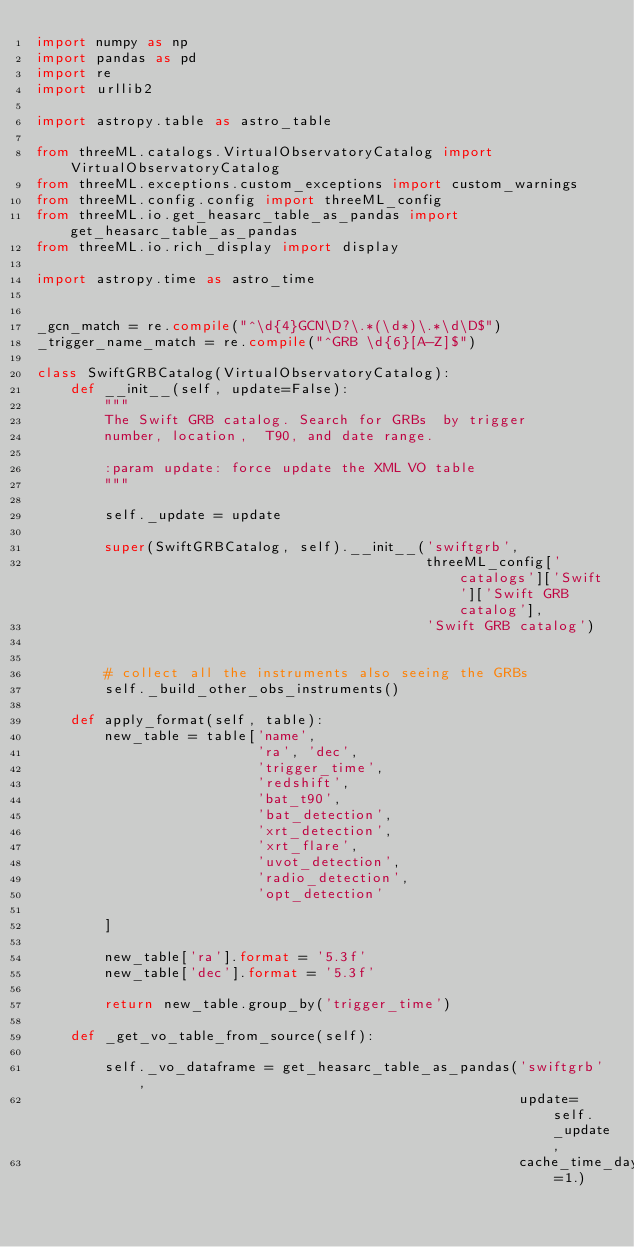<code> <loc_0><loc_0><loc_500><loc_500><_Python_>import numpy as np
import pandas as pd
import re
import urllib2

import astropy.table as astro_table

from threeML.catalogs.VirtualObservatoryCatalog import VirtualObservatoryCatalog
from threeML.exceptions.custom_exceptions import custom_warnings
from threeML.config.config import threeML_config
from threeML.io.get_heasarc_table_as_pandas import get_heasarc_table_as_pandas
from threeML.io.rich_display import display

import astropy.time as astro_time


_gcn_match = re.compile("^\d{4}GCN\D?\.*(\d*)\.*\d\D$")
_trigger_name_match = re.compile("^GRB \d{6}[A-Z]$")

class SwiftGRBCatalog(VirtualObservatoryCatalog):
    def __init__(self, update=False):
        """
        The Swift GRB catalog. Search for GRBs  by trigger
        number, location,  T90, and date range.

        :param update: force update the XML VO table
        """

        self._update = update

        super(SwiftGRBCatalog, self).__init__('swiftgrb',
                                              threeML_config['catalogs']['Swift']['Swift GRB catalog'],
                                              'Swift GRB catalog')


        # collect all the instruments also seeing the GRBs
        self._build_other_obs_instruments()

    def apply_format(self, table):
        new_table = table['name',
                          'ra', 'dec',
                          'trigger_time',
                          'redshift',
                          'bat_t90',
                          'bat_detection',
                          'xrt_detection',
                          'xrt_flare',
                          'uvot_detection',
                          'radio_detection',
                          'opt_detection'

        ]

        new_table['ra'].format = '5.3f'
        new_table['dec'].format = '5.3f'

        return new_table.group_by('trigger_time')

    def _get_vo_table_from_source(self):

        self._vo_dataframe = get_heasarc_table_as_pandas('swiftgrb',
                                                         update=self._update,
                                                         cache_time_days=1.)
</code> 